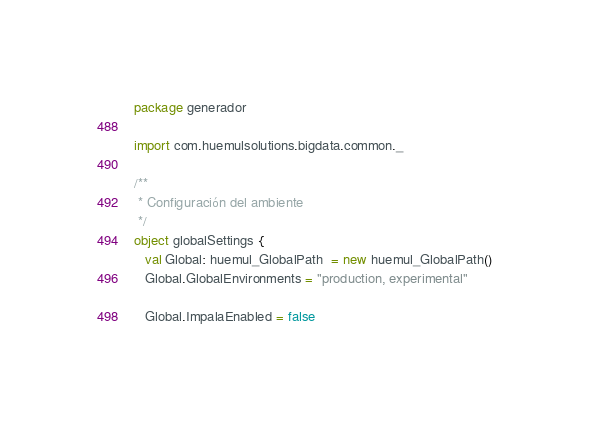Convert code to text. <code><loc_0><loc_0><loc_500><loc_500><_Scala_>package generador

import com.huemulsolutions.bigdata.common._

/**
 * Configuración del ambiente
 */
object globalSettings {
   val Global: huemul_GlobalPath  = new huemul_GlobalPath()
   Global.GlobalEnvironments = "production, experimental"
   
   Global.ImpalaEnabled = false
   </code> 